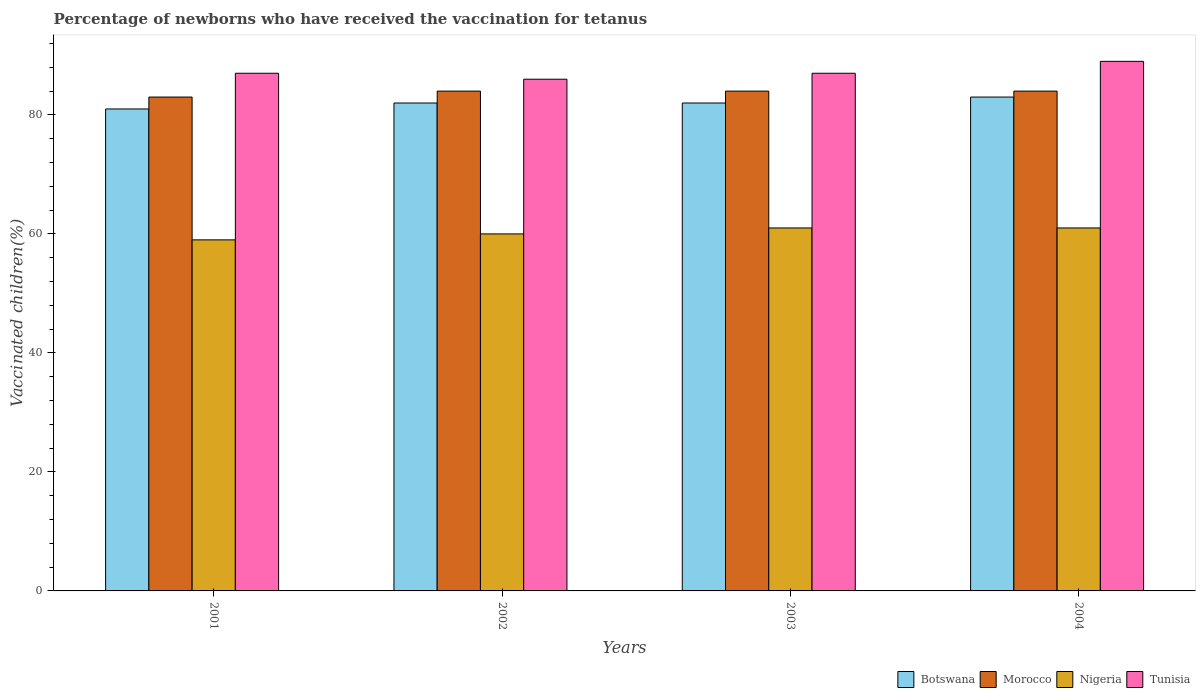How many groups of bars are there?
Ensure brevity in your answer.  4. How many bars are there on the 3rd tick from the left?
Ensure brevity in your answer.  4. What is the percentage of vaccinated children in Morocco in 2003?
Keep it short and to the point. 84. Across all years, what is the maximum percentage of vaccinated children in Morocco?
Provide a succinct answer. 84. What is the total percentage of vaccinated children in Nigeria in the graph?
Ensure brevity in your answer.  241. What is the average percentage of vaccinated children in Tunisia per year?
Offer a very short reply. 87.25. What is the ratio of the percentage of vaccinated children in Botswana in 2001 to that in 2004?
Provide a short and direct response. 0.98. Is the percentage of vaccinated children in Botswana in 2001 less than that in 2004?
Offer a very short reply. Yes. What is the difference between the highest and the lowest percentage of vaccinated children in Nigeria?
Your answer should be compact. 2. What does the 4th bar from the left in 2002 represents?
Ensure brevity in your answer.  Tunisia. What does the 2nd bar from the right in 2003 represents?
Make the answer very short. Nigeria. How many years are there in the graph?
Offer a very short reply. 4. Does the graph contain grids?
Provide a short and direct response. No. How are the legend labels stacked?
Offer a very short reply. Horizontal. What is the title of the graph?
Offer a very short reply. Percentage of newborns who have received the vaccination for tetanus. What is the label or title of the X-axis?
Keep it short and to the point. Years. What is the label or title of the Y-axis?
Provide a succinct answer. Vaccinated children(%). What is the Vaccinated children(%) of Botswana in 2002?
Offer a very short reply. 82. What is the Vaccinated children(%) of Morocco in 2002?
Ensure brevity in your answer.  84. What is the Vaccinated children(%) in Nigeria in 2002?
Make the answer very short. 60. What is the Vaccinated children(%) of Tunisia in 2002?
Provide a succinct answer. 86. What is the Vaccinated children(%) of Botswana in 2003?
Make the answer very short. 82. What is the Vaccinated children(%) of Nigeria in 2003?
Offer a very short reply. 61. What is the Vaccinated children(%) in Botswana in 2004?
Make the answer very short. 83. What is the Vaccinated children(%) in Morocco in 2004?
Offer a very short reply. 84. What is the Vaccinated children(%) of Tunisia in 2004?
Ensure brevity in your answer.  89. Across all years, what is the maximum Vaccinated children(%) of Morocco?
Your response must be concise. 84. Across all years, what is the maximum Vaccinated children(%) of Nigeria?
Keep it short and to the point. 61. Across all years, what is the maximum Vaccinated children(%) in Tunisia?
Your answer should be compact. 89. Across all years, what is the minimum Vaccinated children(%) in Botswana?
Offer a very short reply. 81. Across all years, what is the minimum Vaccinated children(%) of Tunisia?
Provide a short and direct response. 86. What is the total Vaccinated children(%) in Botswana in the graph?
Ensure brevity in your answer.  328. What is the total Vaccinated children(%) in Morocco in the graph?
Your response must be concise. 335. What is the total Vaccinated children(%) in Nigeria in the graph?
Provide a short and direct response. 241. What is the total Vaccinated children(%) in Tunisia in the graph?
Give a very brief answer. 349. What is the difference between the Vaccinated children(%) of Botswana in 2001 and that in 2002?
Your response must be concise. -1. What is the difference between the Vaccinated children(%) of Morocco in 2001 and that in 2002?
Make the answer very short. -1. What is the difference between the Vaccinated children(%) in Tunisia in 2001 and that in 2002?
Give a very brief answer. 1. What is the difference between the Vaccinated children(%) in Morocco in 2001 and that in 2003?
Ensure brevity in your answer.  -1. What is the difference between the Vaccinated children(%) in Morocco in 2001 and that in 2004?
Offer a very short reply. -1. What is the difference between the Vaccinated children(%) of Nigeria in 2001 and that in 2004?
Ensure brevity in your answer.  -2. What is the difference between the Vaccinated children(%) in Morocco in 2002 and that in 2003?
Your answer should be very brief. 0. What is the difference between the Vaccinated children(%) in Nigeria in 2002 and that in 2003?
Make the answer very short. -1. What is the difference between the Vaccinated children(%) of Botswana in 2002 and that in 2004?
Keep it short and to the point. -1. What is the difference between the Vaccinated children(%) of Morocco in 2002 and that in 2004?
Give a very brief answer. 0. What is the difference between the Vaccinated children(%) in Tunisia in 2002 and that in 2004?
Keep it short and to the point. -3. What is the difference between the Vaccinated children(%) in Morocco in 2003 and that in 2004?
Your response must be concise. 0. What is the difference between the Vaccinated children(%) in Nigeria in 2003 and that in 2004?
Ensure brevity in your answer.  0. What is the difference between the Vaccinated children(%) of Botswana in 2001 and the Vaccinated children(%) of Morocco in 2002?
Ensure brevity in your answer.  -3. What is the difference between the Vaccinated children(%) in Botswana in 2001 and the Vaccinated children(%) in Nigeria in 2002?
Keep it short and to the point. 21. What is the difference between the Vaccinated children(%) of Botswana in 2001 and the Vaccinated children(%) of Tunisia in 2002?
Offer a very short reply. -5. What is the difference between the Vaccinated children(%) in Botswana in 2001 and the Vaccinated children(%) in Tunisia in 2003?
Provide a short and direct response. -6. What is the difference between the Vaccinated children(%) in Morocco in 2001 and the Vaccinated children(%) in Nigeria in 2003?
Offer a very short reply. 22. What is the difference between the Vaccinated children(%) of Botswana in 2001 and the Vaccinated children(%) of Morocco in 2004?
Make the answer very short. -3. What is the difference between the Vaccinated children(%) in Botswana in 2001 and the Vaccinated children(%) in Nigeria in 2004?
Offer a very short reply. 20. What is the difference between the Vaccinated children(%) of Morocco in 2001 and the Vaccinated children(%) of Nigeria in 2004?
Provide a short and direct response. 22. What is the difference between the Vaccinated children(%) of Botswana in 2002 and the Vaccinated children(%) of Nigeria in 2003?
Keep it short and to the point. 21. What is the difference between the Vaccinated children(%) in Morocco in 2002 and the Vaccinated children(%) in Nigeria in 2003?
Offer a terse response. 23. What is the difference between the Vaccinated children(%) in Nigeria in 2002 and the Vaccinated children(%) in Tunisia in 2003?
Provide a short and direct response. -27. What is the difference between the Vaccinated children(%) in Botswana in 2002 and the Vaccinated children(%) in Morocco in 2004?
Your response must be concise. -2. What is the difference between the Vaccinated children(%) of Botswana in 2002 and the Vaccinated children(%) of Nigeria in 2004?
Provide a succinct answer. 21. What is the difference between the Vaccinated children(%) in Morocco in 2002 and the Vaccinated children(%) in Tunisia in 2004?
Offer a very short reply. -5. What is the difference between the Vaccinated children(%) of Nigeria in 2002 and the Vaccinated children(%) of Tunisia in 2004?
Make the answer very short. -29. What is the difference between the Vaccinated children(%) in Botswana in 2003 and the Vaccinated children(%) in Morocco in 2004?
Your answer should be compact. -2. What is the difference between the Vaccinated children(%) of Botswana in 2003 and the Vaccinated children(%) of Nigeria in 2004?
Offer a terse response. 21. What is the difference between the Vaccinated children(%) in Morocco in 2003 and the Vaccinated children(%) in Nigeria in 2004?
Your answer should be very brief. 23. What is the average Vaccinated children(%) of Botswana per year?
Ensure brevity in your answer.  82. What is the average Vaccinated children(%) of Morocco per year?
Make the answer very short. 83.75. What is the average Vaccinated children(%) of Nigeria per year?
Offer a very short reply. 60.25. What is the average Vaccinated children(%) in Tunisia per year?
Provide a short and direct response. 87.25. In the year 2001, what is the difference between the Vaccinated children(%) of Botswana and Vaccinated children(%) of Nigeria?
Provide a succinct answer. 22. In the year 2001, what is the difference between the Vaccinated children(%) in Morocco and Vaccinated children(%) in Nigeria?
Offer a very short reply. 24. In the year 2001, what is the difference between the Vaccinated children(%) of Morocco and Vaccinated children(%) of Tunisia?
Your answer should be very brief. -4. In the year 2002, what is the difference between the Vaccinated children(%) of Botswana and Vaccinated children(%) of Morocco?
Make the answer very short. -2. In the year 2002, what is the difference between the Vaccinated children(%) of Botswana and Vaccinated children(%) of Nigeria?
Provide a short and direct response. 22. In the year 2002, what is the difference between the Vaccinated children(%) of Botswana and Vaccinated children(%) of Tunisia?
Offer a terse response. -4. In the year 2002, what is the difference between the Vaccinated children(%) in Morocco and Vaccinated children(%) in Nigeria?
Make the answer very short. 24. In the year 2002, what is the difference between the Vaccinated children(%) in Morocco and Vaccinated children(%) in Tunisia?
Keep it short and to the point. -2. In the year 2003, what is the difference between the Vaccinated children(%) of Morocco and Vaccinated children(%) of Nigeria?
Your answer should be very brief. 23. In the year 2004, what is the difference between the Vaccinated children(%) of Botswana and Vaccinated children(%) of Morocco?
Give a very brief answer. -1. In the year 2004, what is the difference between the Vaccinated children(%) of Botswana and Vaccinated children(%) of Nigeria?
Provide a succinct answer. 22. In the year 2004, what is the difference between the Vaccinated children(%) of Botswana and Vaccinated children(%) of Tunisia?
Keep it short and to the point. -6. In the year 2004, what is the difference between the Vaccinated children(%) in Morocco and Vaccinated children(%) in Tunisia?
Your answer should be very brief. -5. What is the ratio of the Vaccinated children(%) of Nigeria in 2001 to that in 2002?
Give a very brief answer. 0.98. What is the ratio of the Vaccinated children(%) in Tunisia in 2001 to that in 2002?
Your response must be concise. 1.01. What is the ratio of the Vaccinated children(%) of Nigeria in 2001 to that in 2003?
Make the answer very short. 0.97. What is the ratio of the Vaccinated children(%) in Botswana in 2001 to that in 2004?
Give a very brief answer. 0.98. What is the ratio of the Vaccinated children(%) of Nigeria in 2001 to that in 2004?
Offer a very short reply. 0.97. What is the ratio of the Vaccinated children(%) in Tunisia in 2001 to that in 2004?
Provide a succinct answer. 0.98. What is the ratio of the Vaccinated children(%) of Nigeria in 2002 to that in 2003?
Keep it short and to the point. 0.98. What is the ratio of the Vaccinated children(%) in Nigeria in 2002 to that in 2004?
Your answer should be very brief. 0.98. What is the ratio of the Vaccinated children(%) of Tunisia in 2002 to that in 2004?
Provide a succinct answer. 0.97. What is the ratio of the Vaccinated children(%) of Botswana in 2003 to that in 2004?
Your answer should be compact. 0.99. What is the ratio of the Vaccinated children(%) of Nigeria in 2003 to that in 2004?
Offer a very short reply. 1. What is the ratio of the Vaccinated children(%) in Tunisia in 2003 to that in 2004?
Make the answer very short. 0.98. What is the difference between the highest and the lowest Vaccinated children(%) of Tunisia?
Ensure brevity in your answer.  3. 